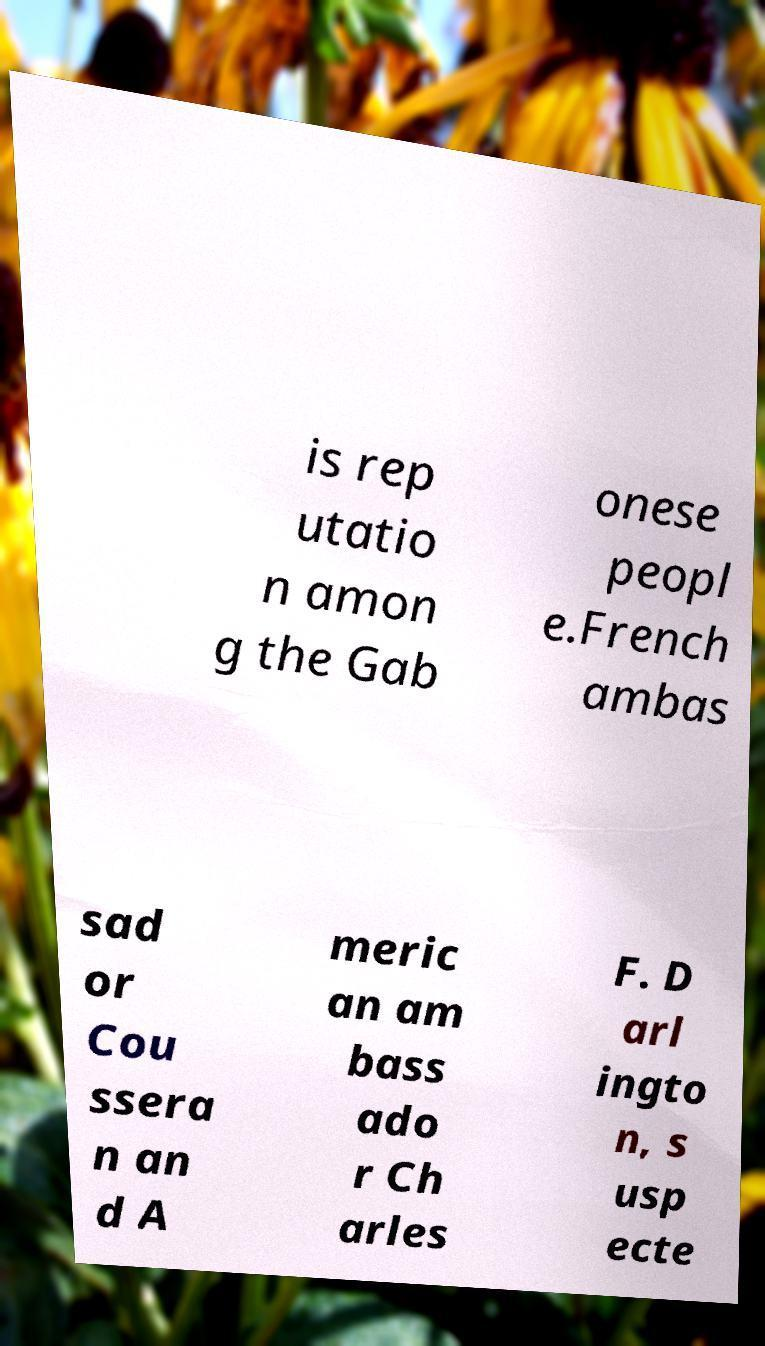Can you accurately transcribe the text from the provided image for me? is rep utatio n amon g the Gab onese peopl e.French ambas sad or Cou ssera n an d A meric an am bass ado r Ch arles F. D arl ingto n, s usp ecte 